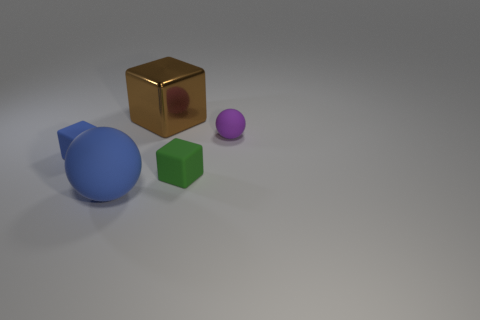Are there any other things that have the same material as the tiny blue cube?
Make the answer very short. Yes. What number of objects are cubes that are right of the large cube or objects that are in front of the brown shiny cube?
Make the answer very short. 4. Is there any other thing of the same color as the small ball?
Keep it short and to the point. No. Is the number of large rubber spheres in front of the big brown shiny thing the same as the number of large objects that are left of the small green block?
Ensure brevity in your answer.  No. Is the number of tiny purple matte balls that are behind the brown block greater than the number of small cyan shiny objects?
Provide a short and direct response. No. How many objects are either big objects that are to the left of the big metallic cube or big cyan objects?
Keep it short and to the point. 1. What number of spheres are the same material as the green block?
Provide a short and direct response. 2. The thing that is the same color as the big sphere is what shape?
Give a very brief answer. Cube. Is there a small green thing of the same shape as the big shiny object?
Ensure brevity in your answer.  Yes. What shape is the purple rubber thing that is the same size as the blue block?
Keep it short and to the point. Sphere. 